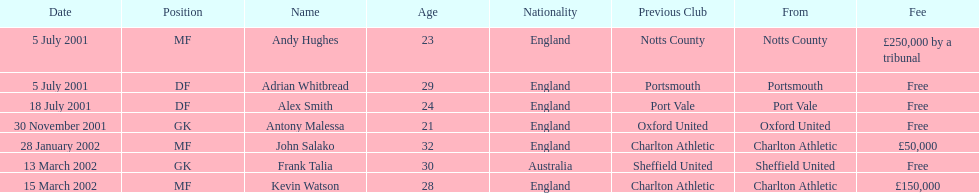Who transferred after 30 november 2001? John Salako, Frank Talia, Kevin Watson. 